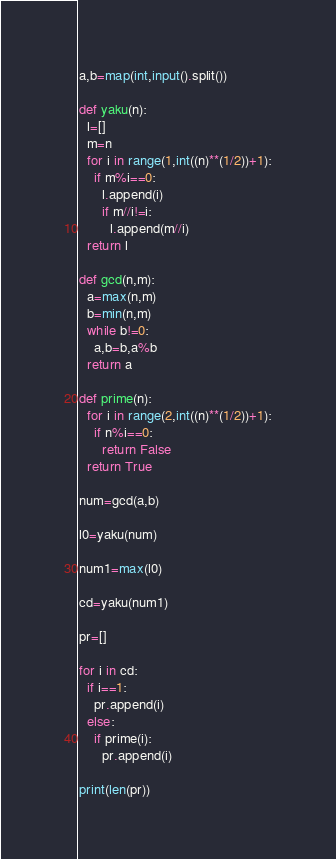<code> <loc_0><loc_0><loc_500><loc_500><_Python_>a,b=map(int,input().split())

def yaku(n):
  l=[]
  m=n
  for i in range(1,int((n)**(1/2))+1):
    if m%i==0:
      l.append(i)
      if m//i!=i:
        l.append(m//i)
  return l

def gcd(n,m):
  a=max(n,m)
  b=min(n,m)
  while b!=0:
    a,b=b,a%b
  return a

def prime(n):
  for i in range(2,int((n)**(1/2))+1):
    if n%i==0:
      return False
  return True

num=gcd(a,b)

l0=yaku(num)

num1=max(l0)

cd=yaku(num1)

pr=[]

for i in cd:
  if i==1:
    pr.append(i)
  else:
    if prime(i):
      pr.append(i)

print(len(pr))</code> 